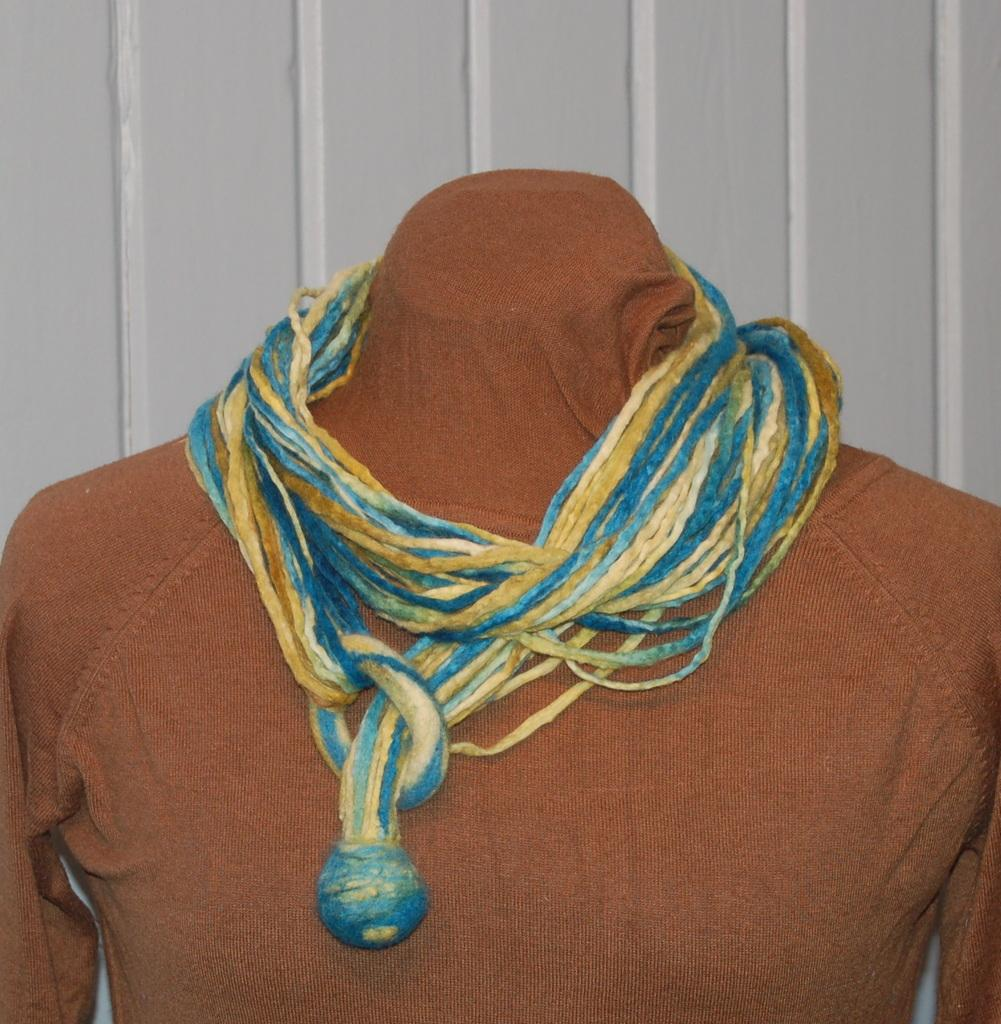What is the main subject of the image? There is a mannequin in the image. What is the mannequin wearing? The mannequin is wearing a dress. Are there any additional details visible on the mannequin? Yes, there are threads on the mannequin. What can be seen in the background of the image? There is a wall visible in the background of the image. What is the name of the mannequin's mom in the image? There is no information about the mannequin's mom in the image, as mannequins do not have parents. How many buttons can be seen on the dress the mannequin is wearing? There are no buttons visible on the dress the mannequin is wearing; it only has threads. 